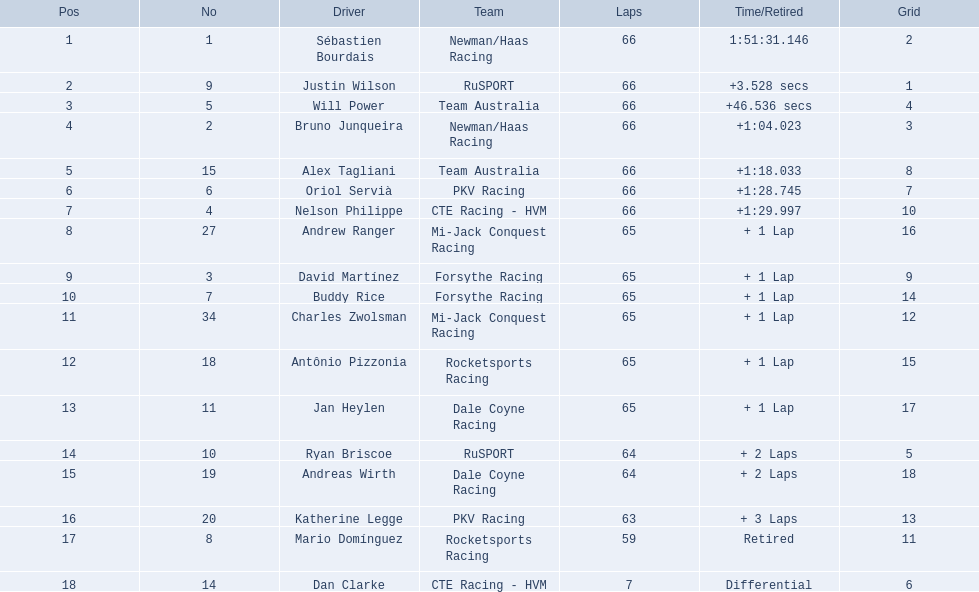What drivers started in the top 10? Sébastien Bourdais, Justin Wilson, Will Power, Bruno Junqueira, Alex Tagliani, Oriol Servià, Nelson Philippe, Ryan Briscoe, Dan Clarke. Which of those drivers completed all 66 laps? Sébastien Bourdais, Justin Wilson, Will Power, Bruno Junqueira, Alex Tagliani, Oriol Servià, Nelson Philippe. Can you give me this table as a dict? {'header': ['Pos', 'No', 'Driver', 'Team', 'Laps', 'Time/Retired', 'Grid'], 'rows': [['1', '1', 'Sébastien Bourdais', 'Newman/Haas Racing', '66', '1:51:31.146', '2'], ['2', '9', 'Justin Wilson', 'RuSPORT', '66', '+3.528 secs', '1'], ['3', '5', 'Will Power', 'Team Australia', '66', '+46.536 secs', '4'], ['4', '2', 'Bruno Junqueira', 'Newman/Haas Racing', '66', '+1:04.023', '3'], ['5', '15', 'Alex Tagliani', 'Team Australia', '66', '+1:18.033', '8'], ['6', '6', 'Oriol Servià', 'PKV Racing', '66', '+1:28.745', '7'], ['7', '4', 'Nelson Philippe', 'CTE Racing - HVM', '66', '+1:29.997', '10'], ['8', '27', 'Andrew Ranger', 'Mi-Jack Conquest Racing', '65', '+ 1 Lap', '16'], ['9', '3', 'David Martínez', 'Forsythe Racing', '65', '+ 1 Lap', '9'], ['10', '7', 'Buddy Rice', 'Forsythe Racing', '65', '+ 1 Lap', '14'], ['11', '34', 'Charles Zwolsman', 'Mi-Jack Conquest Racing', '65', '+ 1 Lap', '12'], ['12', '18', 'Antônio Pizzonia', 'Rocketsports Racing', '65', '+ 1 Lap', '15'], ['13', '11', 'Jan Heylen', 'Dale Coyne Racing', '65', '+ 1 Lap', '17'], ['14', '10', 'Ryan Briscoe', 'RuSPORT', '64', '+ 2 Laps', '5'], ['15', '19', 'Andreas Wirth', 'Dale Coyne Racing', '64', '+ 2 Laps', '18'], ['16', '20', 'Katherine Legge', 'PKV Racing', '63', '+ 3 Laps', '13'], ['17', '8', 'Mario Domínguez', 'Rocketsports Racing', '59', 'Retired', '11'], ['18', '14', 'Dan Clarke', 'CTE Racing - HVM', '7', 'Differential', '6']]} Whom of these did not drive for team australia? Sébastien Bourdais, Justin Wilson, Bruno Junqueira, Oriol Servià, Nelson Philippe. Which of these drivers finished more then a minuet after the winner? Bruno Junqueira, Oriol Servià, Nelson Philippe. Which of these drivers had the highest car number? Oriol Servià. 